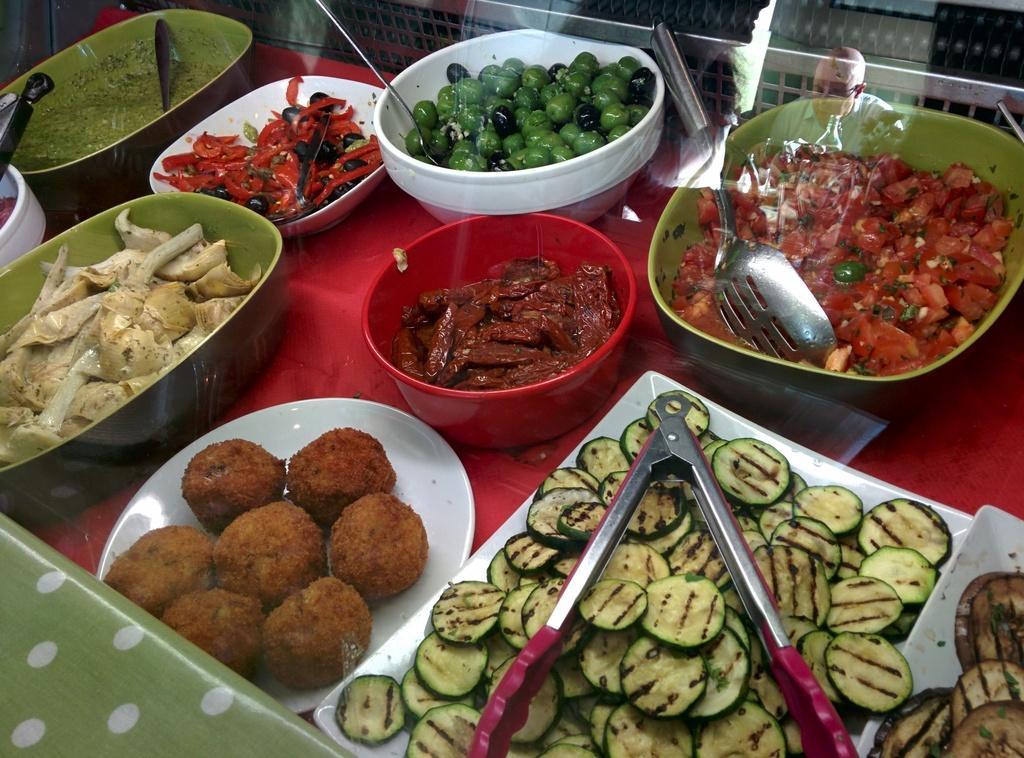Could you give a brief overview of what you see in this image? There is a red surface. On that there are bowls and plates. On the bowls and plates there are food items. Also there are spoons and tongs. And there is a glass wall. On that we can see a reflection of a person. 